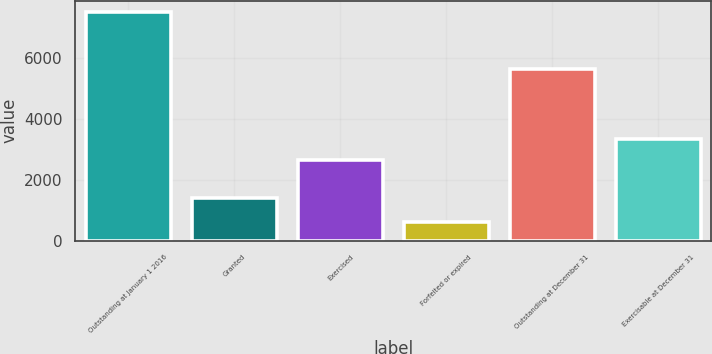Convert chart to OTSL. <chart><loc_0><loc_0><loc_500><loc_500><bar_chart><fcel>Outstanding at January 1 2016<fcel>Granted<fcel>Exercised<fcel>Forfeited or expired<fcel>Outstanding at December 31<fcel>Exercisable at December 31<nl><fcel>7507<fcel>1387<fcel>2645<fcel>606<fcel>5643<fcel>3335.1<nl></chart> 